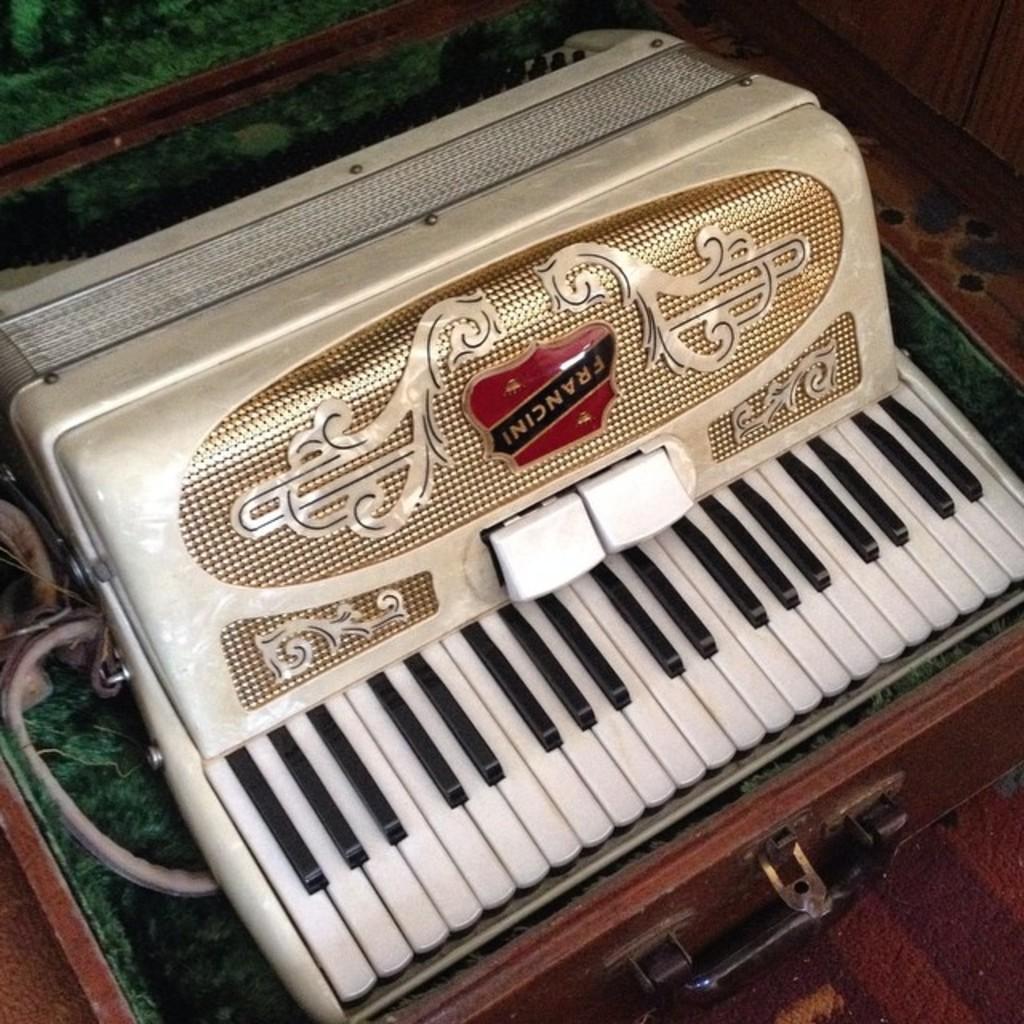Describe this image in one or two sentences. Here we can see a piano, and black and white keys on it and it is on the table. 